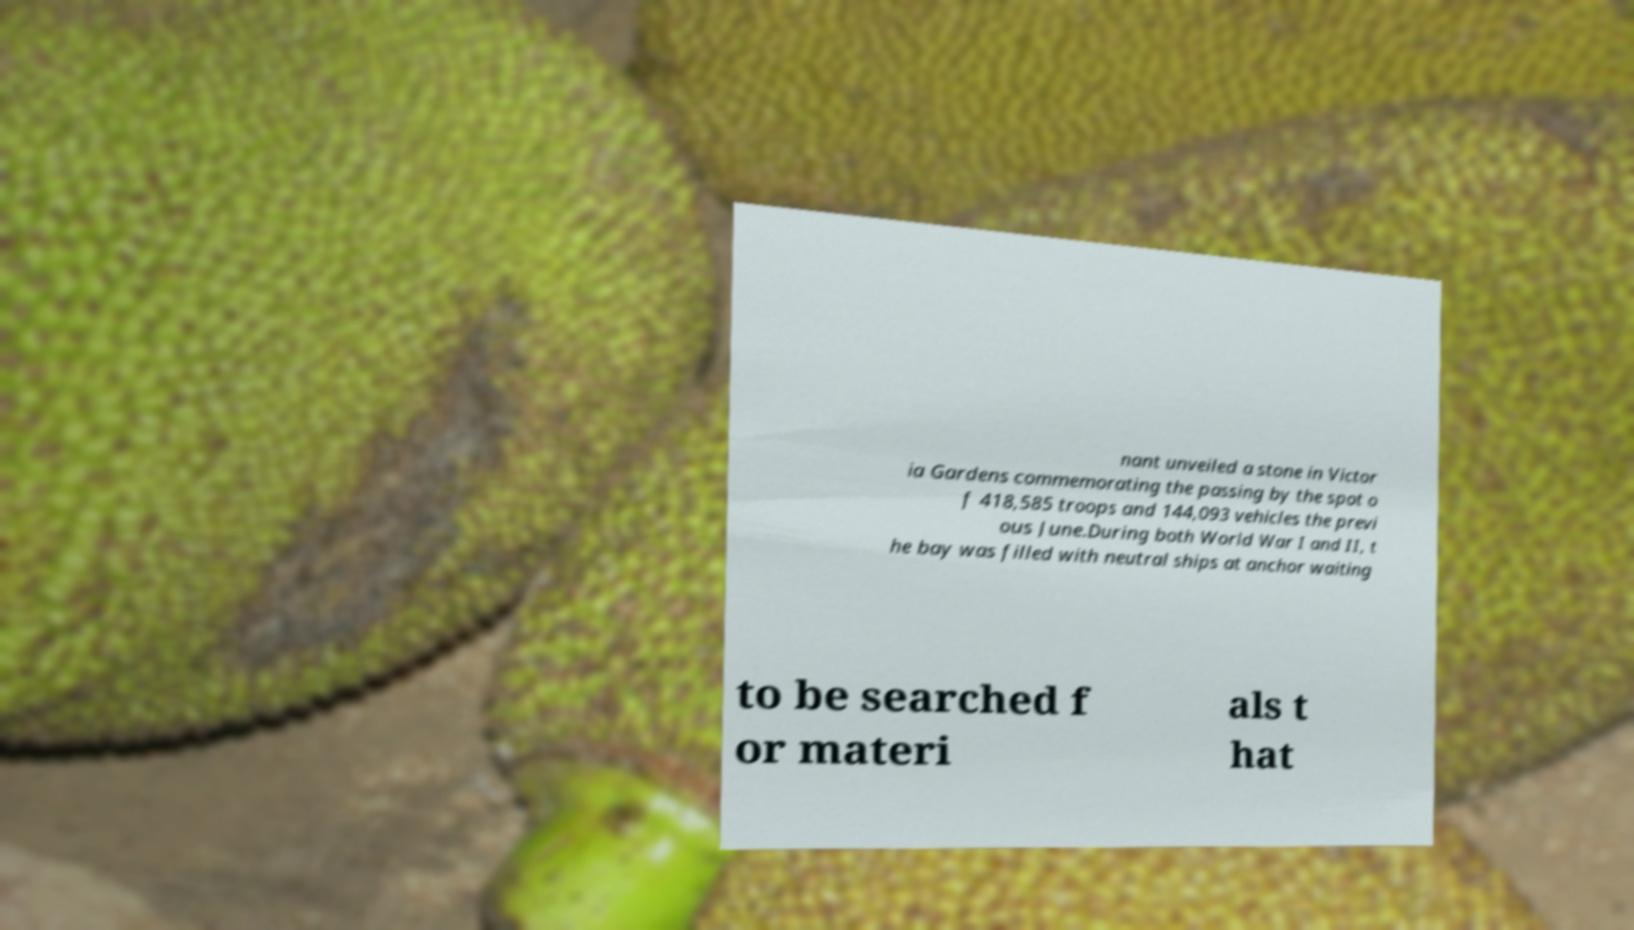Can you read and provide the text displayed in the image?This photo seems to have some interesting text. Can you extract and type it out for me? nant unveiled a stone in Victor ia Gardens commemorating the passing by the spot o f 418,585 troops and 144,093 vehicles the previ ous June.During both World War I and II, t he bay was filled with neutral ships at anchor waiting to be searched f or materi als t hat 